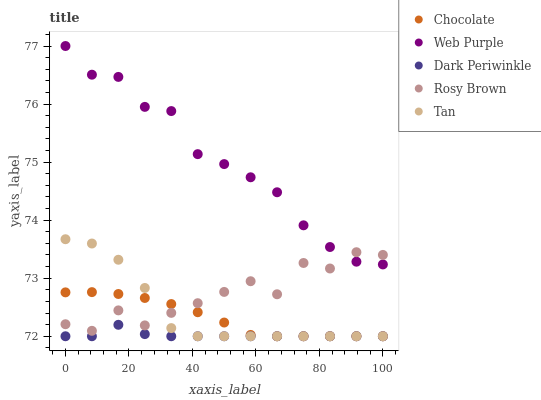Does Dark Periwinkle have the minimum area under the curve?
Answer yes or no. Yes. Does Web Purple have the maximum area under the curve?
Answer yes or no. Yes. Does Rosy Brown have the minimum area under the curve?
Answer yes or no. No. Does Rosy Brown have the maximum area under the curve?
Answer yes or no. No. Is Chocolate the smoothest?
Answer yes or no. Yes. Is Rosy Brown the roughest?
Answer yes or no. Yes. Is Tan the smoothest?
Answer yes or no. No. Is Tan the roughest?
Answer yes or no. No. Does Tan have the lowest value?
Answer yes or no. Yes. Does Rosy Brown have the lowest value?
Answer yes or no. No. Does Web Purple have the highest value?
Answer yes or no. Yes. Does Rosy Brown have the highest value?
Answer yes or no. No. Is Dark Periwinkle less than Rosy Brown?
Answer yes or no. Yes. Is Rosy Brown greater than Dark Periwinkle?
Answer yes or no. Yes. Does Chocolate intersect Tan?
Answer yes or no. Yes. Is Chocolate less than Tan?
Answer yes or no. No. Is Chocolate greater than Tan?
Answer yes or no. No. Does Dark Periwinkle intersect Rosy Brown?
Answer yes or no. No. 